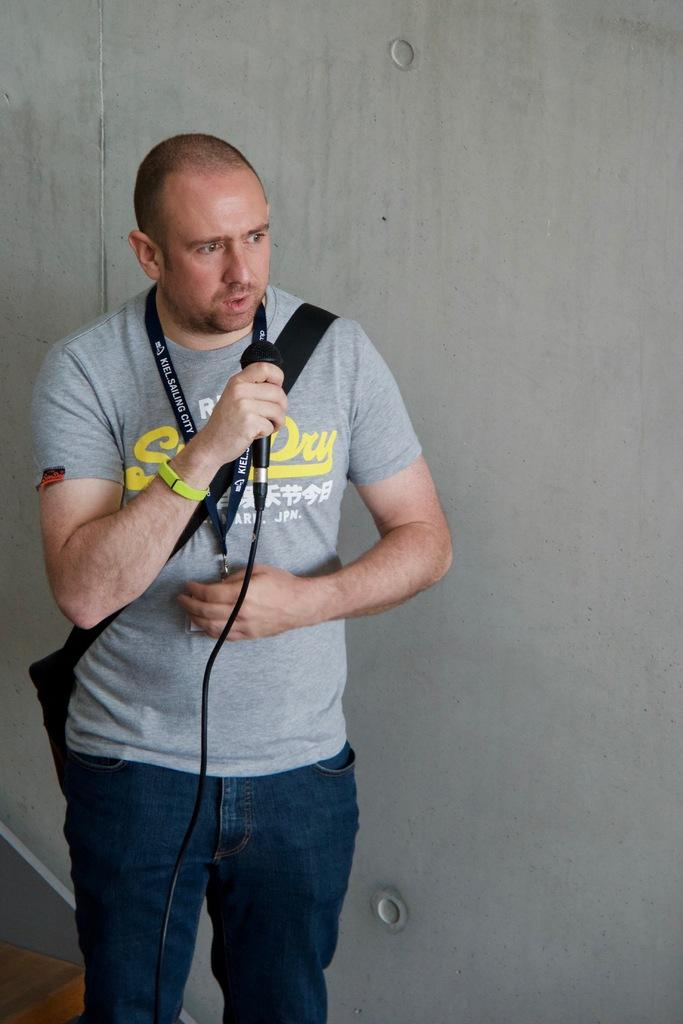What is the main subject of the image? There is a man in the image. What is the man doing in the image? The man is standing in the image. What object is the man holding in the image? The man is holding a black microphone in the image. What can be seen in the background of the image? There is a white wall in the image. How does the man use the brake in the image? There is no brake present in the image; the man is holding a black microphone. Can you tell me how many cows are visible in the image? There are no cows present in the image; the main subject is a man holding a microphone in front of a white wall. 